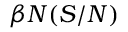<formula> <loc_0><loc_0><loc_500><loc_500>\beta N ( S / N )</formula> 